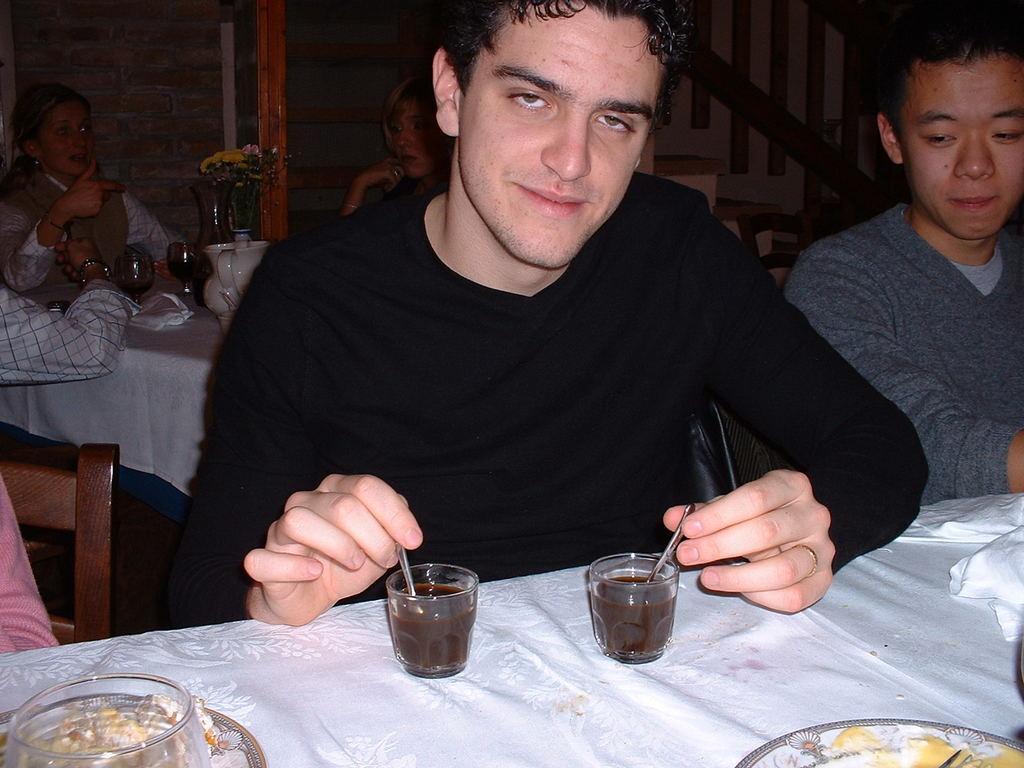Describe this image in one or two sentences. In this image there is a table on that table there is a cloth, plates, bowl and two cups in that cups there is liquid and spoons, behind the table there are three persons sitting on chairs, one person is holding spoon with his hands, in the background there another table, on that table there is a cloth, glasses, flower vase, around the table there are people sitting on chairs, there is a wall and stairs. 